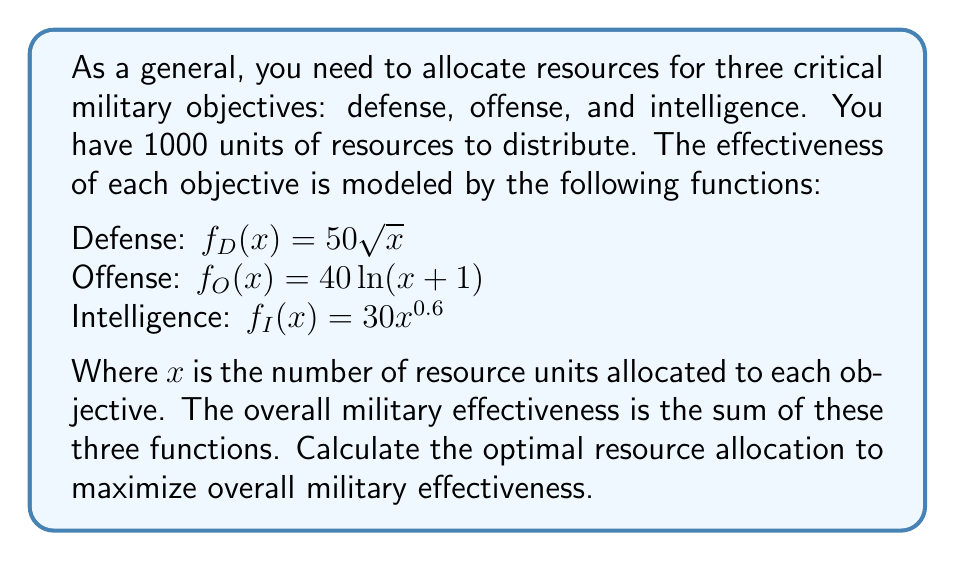Can you solve this math problem? To solve this problem, we'll use the method of Lagrange multipliers, as we're dealing with a constrained optimization problem.

1) Let's define our objective function:
   $F(x,y,z) = 50\sqrt{x} + 40\ln(y+1) + 30z^{0.6}$

2) Our constraint is:
   $g(x,y,z) = x + y + z - 1000 = 0$

3) We form the Lagrangian:
   $L(x,y,z,\lambda) = 50\sqrt{x} + 40\ln(y+1) + 30z^{0.6} - \lambda(x + y + z - 1000)$

4) We set the partial derivatives equal to zero:

   $\frac{\partial L}{\partial x} = \frac{25}{\sqrt{x}} - \lambda = 0$
   
   $\frac{\partial L}{\partial y} = \frac{40}{y+1} - \lambda = 0$
   
   $\frac{\partial L}{\partial z} = \frac{18}{z^{0.4}} - \lambda = 0$
   
   $\frac{\partial L}{\partial \lambda} = x + y + z - 1000 = 0$

5) From these equations, we can derive:

   $x = \frac{625}{\lambda^2}$
   
   $y = \frac{40}{\lambda} - 1$
   
   $z = (\frac{18}{\lambda})^{2.5}$

6) Substituting these into the constraint equation:

   $\frac{625}{\lambda^2} + \frac{40}{\lambda} - 1 + (\frac{18}{\lambda})^{2.5} = 1000$

7) This equation can be solved numerically. Using a computer algebra system or numerical methods, we find:

   $\lambda \approx 0.3162$

8) Substituting this value back into our expressions for x, y, and z:

   $x \approx 625$
   $y \approx 126$
   $z \approx 249$

These values sum to 1000, satisfying our constraint.
Answer: The optimal resource allocation is approximately:
Defense: 625 units
Offense: 126 units
Intelligence: 249 units 